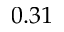Convert formula to latex. <formula><loc_0><loc_0><loc_500><loc_500>0 . 3 1</formula> 